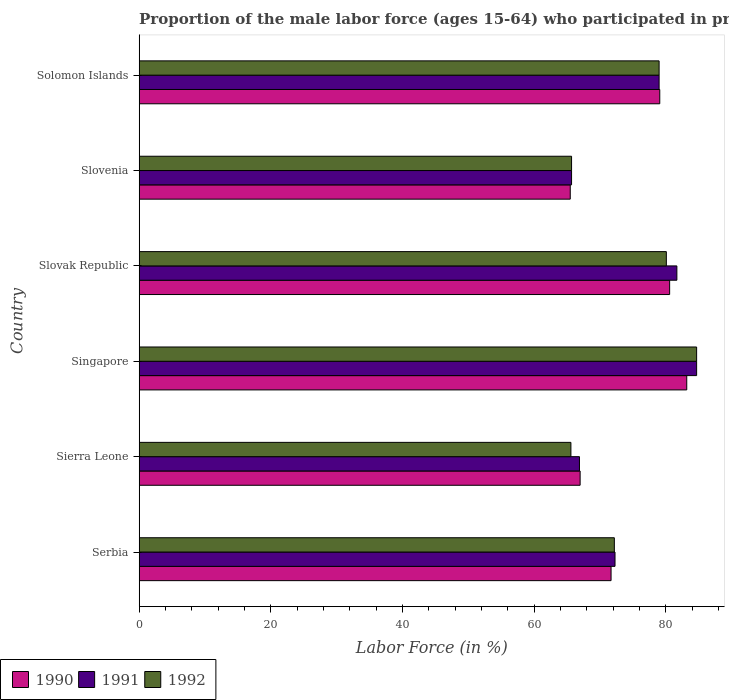Are the number of bars per tick equal to the number of legend labels?
Your answer should be very brief. Yes. How many bars are there on the 5th tick from the bottom?
Provide a short and direct response. 3. What is the label of the 2nd group of bars from the top?
Keep it short and to the point. Slovenia. In how many cases, is the number of bars for a given country not equal to the number of legend labels?
Make the answer very short. 0. Across all countries, what is the maximum proportion of the male labor force who participated in production in 1990?
Provide a short and direct response. 83.2. Across all countries, what is the minimum proportion of the male labor force who participated in production in 1990?
Keep it short and to the point. 65.5. In which country was the proportion of the male labor force who participated in production in 1991 maximum?
Your answer should be compact. Singapore. In which country was the proportion of the male labor force who participated in production in 1992 minimum?
Your response must be concise. Sierra Leone. What is the total proportion of the male labor force who participated in production in 1992 in the graph?
Ensure brevity in your answer.  447.3. What is the difference between the proportion of the male labor force who participated in production in 1991 in Slovak Republic and that in Solomon Islands?
Provide a succinct answer. 2.7. What is the difference between the proportion of the male labor force who participated in production in 1990 in Slovak Republic and the proportion of the male labor force who participated in production in 1992 in Slovenia?
Your answer should be very brief. 14.9. What is the average proportion of the male labor force who participated in production in 1991 per country?
Your response must be concise. 75.05. What is the difference between the proportion of the male labor force who participated in production in 1990 and proportion of the male labor force who participated in production in 1992 in Solomon Islands?
Make the answer very short. 0.1. In how many countries, is the proportion of the male labor force who participated in production in 1991 greater than 4 %?
Offer a very short reply. 6. What is the ratio of the proportion of the male labor force who participated in production in 1992 in Sierra Leone to that in Solomon Islands?
Provide a short and direct response. 0.83. Is the difference between the proportion of the male labor force who participated in production in 1990 in Serbia and Slovenia greater than the difference between the proportion of the male labor force who participated in production in 1992 in Serbia and Slovenia?
Offer a very short reply. No. What is the difference between the highest and the second highest proportion of the male labor force who participated in production in 1990?
Offer a very short reply. 2.6. What is the difference between the highest and the lowest proportion of the male labor force who participated in production in 1990?
Your response must be concise. 17.7. In how many countries, is the proportion of the male labor force who participated in production in 1992 greater than the average proportion of the male labor force who participated in production in 1992 taken over all countries?
Keep it short and to the point. 3. What does the 2nd bar from the bottom in Solomon Islands represents?
Provide a succinct answer. 1991. Is it the case that in every country, the sum of the proportion of the male labor force who participated in production in 1991 and proportion of the male labor force who participated in production in 1992 is greater than the proportion of the male labor force who participated in production in 1990?
Make the answer very short. Yes. How many bars are there?
Provide a succinct answer. 18. Are all the bars in the graph horizontal?
Offer a very short reply. Yes. What is the difference between two consecutive major ticks on the X-axis?
Ensure brevity in your answer.  20. Where does the legend appear in the graph?
Provide a succinct answer. Bottom left. How are the legend labels stacked?
Provide a short and direct response. Horizontal. What is the title of the graph?
Provide a short and direct response. Proportion of the male labor force (ages 15-64) who participated in production. What is the Labor Force (in %) in 1990 in Serbia?
Make the answer very short. 71.7. What is the Labor Force (in %) in 1991 in Serbia?
Offer a terse response. 72.3. What is the Labor Force (in %) in 1992 in Serbia?
Your response must be concise. 72.2. What is the Labor Force (in %) of 1990 in Sierra Leone?
Keep it short and to the point. 67. What is the Labor Force (in %) of 1991 in Sierra Leone?
Your answer should be compact. 66.9. What is the Labor Force (in %) of 1992 in Sierra Leone?
Offer a terse response. 65.6. What is the Labor Force (in %) of 1990 in Singapore?
Make the answer very short. 83.2. What is the Labor Force (in %) in 1991 in Singapore?
Provide a short and direct response. 84.7. What is the Labor Force (in %) in 1992 in Singapore?
Provide a succinct answer. 84.7. What is the Labor Force (in %) in 1990 in Slovak Republic?
Your answer should be very brief. 80.6. What is the Labor Force (in %) of 1991 in Slovak Republic?
Make the answer very short. 81.7. What is the Labor Force (in %) of 1992 in Slovak Republic?
Offer a terse response. 80.1. What is the Labor Force (in %) of 1990 in Slovenia?
Offer a very short reply. 65.5. What is the Labor Force (in %) in 1991 in Slovenia?
Keep it short and to the point. 65.7. What is the Labor Force (in %) of 1992 in Slovenia?
Your answer should be very brief. 65.7. What is the Labor Force (in %) in 1990 in Solomon Islands?
Provide a succinct answer. 79.1. What is the Labor Force (in %) of 1991 in Solomon Islands?
Offer a very short reply. 79. What is the Labor Force (in %) of 1992 in Solomon Islands?
Make the answer very short. 79. Across all countries, what is the maximum Labor Force (in %) in 1990?
Ensure brevity in your answer.  83.2. Across all countries, what is the maximum Labor Force (in %) in 1991?
Keep it short and to the point. 84.7. Across all countries, what is the maximum Labor Force (in %) in 1992?
Offer a very short reply. 84.7. Across all countries, what is the minimum Labor Force (in %) in 1990?
Keep it short and to the point. 65.5. Across all countries, what is the minimum Labor Force (in %) in 1991?
Offer a very short reply. 65.7. Across all countries, what is the minimum Labor Force (in %) in 1992?
Offer a terse response. 65.6. What is the total Labor Force (in %) of 1990 in the graph?
Your response must be concise. 447.1. What is the total Labor Force (in %) of 1991 in the graph?
Provide a succinct answer. 450.3. What is the total Labor Force (in %) in 1992 in the graph?
Your response must be concise. 447.3. What is the difference between the Labor Force (in %) in 1990 in Serbia and that in Sierra Leone?
Offer a very short reply. 4.7. What is the difference between the Labor Force (in %) of 1992 in Serbia and that in Sierra Leone?
Make the answer very short. 6.6. What is the difference between the Labor Force (in %) of 1990 in Serbia and that in Singapore?
Provide a succinct answer. -11.5. What is the difference between the Labor Force (in %) in 1991 in Serbia and that in Singapore?
Provide a succinct answer. -12.4. What is the difference between the Labor Force (in %) in 1991 in Serbia and that in Slovak Republic?
Give a very brief answer. -9.4. What is the difference between the Labor Force (in %) of 1992 in Serbia and that in Slovak Republic?
Ensure brevity in your answer.  -7.9. What is the difference between the Labor Force (in %) of 1991 in Serbia and that in Slovenia?
Provide a succinct answer. 6.6. What is the difference between the Labor Force (in %) of 1992 in Serbia and that in Slovenia?
Your answer should be compact. 6.5. What is the difference between the Labor Force (in %) in 1990 in Sierra Leone and that in Singapore?
Provide a short and direct response. -16.2. What is the difference between the Labor Force (in %) of 1991 in Sierra Leone and that in Singapore?
Your answer should be compact. -17.8. What is the difference between the Labor Force (in %) in 1992 in Sierra Leone and that in Singapore?
Your answer should be very brief. -19.1. What is the difference between the Labor Force (in %) in 1990 in Sierra Leone and that in Slovak Republic?
Keep it short and to the point. -13.6. What is the difference between the Labor Force (in %) of 1991 in Sierra Leone and that in Slovak Republic?
Your answer should be very brief. -14.8. What is the difference between the Labor Force (in %) of 1990 in Sierra Leone and that in Slovenia?
Provide a succinct answer. 1.5. What is the difference between the Labor Force (in %) in 1991 in Sierra Leone and that in Slovenia?
Provide a short and direct response. 1.2. What is the difference between the Labor Force (in %) of 1990 in Sierra Leone and that in Solomon Islands?
Your response must be concise. -12.1. What is the difference between the Labor Force (in %) of 1991 in Singapore and that in Slovak Republic?
Your response must be concise. 3. What is the difference between the Labor Force (in %) in 1992 in Singapore and that in Slovak Republic?
Provide a short and direct response. 4.6. What is the difference between the Labor Force (in %) in 1991 in Singapore and that in Slovenia?
Your response must be concise. 19. What is the difference between the Labor Force (in %) in 1992 in Singapore and that in Slovenia?
Provide a succinct answer. 19. What is the difference between the Labor Force (in %) in 1992 in Singapore and that in Solomon Islands?
Keep it short and to the point. 5.7. What is the difference between the Labor Force (in %) in 1991 in Slovak Republic and that in Slovenia?
Offer a terse response. 16. What is the difference between the Labor Force (in %) of 1992 in Slovak Republic and that in Slovenia?
Provide a succinct answer. 14.4. What is the difference between the Labor Force (in %) of 1991 in Slovak Republic and that in Solomon Islands?
Offer a very short reply. 2.7. What is the difference between the Labor Force (in %) in 1992 in Slovak Republic and that in Solomon Islands?
Your response must be concise. 1.1. What is the difference between the Labor Force (in %) of 1990 in Serbia and the Labor Force (in %) of 1991 in Sierra Leone?
Provide a short and direct response. 4.8. What is the difference between the Labor Force (in %) in 1990 in Serbia and the Labor Force (in %) in 1992 in Sierra Leone?
Give a very brief answer. 6.1. What is the difference between the Labor Force (in %) of 1990 in Serbia and the Labor Force (in %) of 1991 in Singapore?
Offer a terse response. -13. What is the difference between the Labor Force (in %) of 1990 in Serbia and the Labor Force (in %) of 1992 in Singapore?
Offer a terse response. -13. What is the difference between the Labor Force (in %) in 1991 in Serbia and the Labor Force (in %) in 1992 in Singapore?
Your answer should be very brief. -12.4. What is the difference between the Labor Force (in %) of 1990 in Serbia and the Labor Force (in %) of 1992 in Slovenia?
Provide a short and direct response. 6. What is the difference between the Labor Force (in %) in 1991 in Serbia and the Labor Force (in %) in 1992 in Slovenia?
Offer a very short reply. 6.6. What is the difference between the Labor Force (in %) of 1990 in Serbia and the Labor Force (in %) of 1992 in Solomon Islands?
Give a very brief answer. -7.3. What is the difference between the Labor Force (in %) of 1990 in Sierra Leone and the Labor Force (in %) of 1991 in Singapore?
Make the answer very short. -17.7. What is the difference between the Labor Force (in %) of 1990 in Sierra Leone and the Labor Force (in %) of 1992 in Singapore?
Offer a very short reply. -17.7. What is the difference between the Labor Force (in %) in 1991 in Sierra Leone and the Labor Force (in %) in 1992 in Singapore?
Provide a short and direct response. -17.8. What is the difference between the Labor Force (in %) of 1990 in Sierra Leone and the Labor Force (in %) of 1991 in Slovak Republic?
Offer a terse response. -14.7. What is the difference between the Labor Force (in %) of 1990 in Sierra Leone and the Labor Force (in %) of 1992 in Slovak Republic?
Keep it short and to the point. -13.1. What is the difference between the Labor Force (in %) in 1991 in Sierra Leone and the Labor Force (in %) in 1992 in Slovak Republic?
Give a very brief answer. -13.2. What is the difference between the Labor Force (in %) in 1990 in Sierra Leone and the Labor Force (in %) in 1991 in Slovenia?
Give a very brief answer. 1.3. What is the difference between the Labor Force (in %) of 1991 in Sierra Leone and the Labor Force (in %) of 1992 in Slovenia?
Make the answer very short. 1.2. What is the difference between the Labor Force (in %) of 1990 in Singapore and the Labor Force (in %) of 1991 in Slovak Republic?
Offer a very short reply. 1.5. What is the difference between the Labor Force (in %) in 1991 in Singapore and the Labor Force (in %) in 1992 in Slovak Republic?
Offer a very short reply. 4.6. What is the difference between the Labor Force (in %) of 1990 in Singapore and the Labor Force (in %) of 1991 in Solomon Islands?
Offer a very short reply. 4.2. What is the difference between the Labor Force (in %) in 1990 in Singapore and the Labor Force (in %) in 1992 in Solomon Islands?
Keep it short and to the point. 4.2. What is the difference between the Labor Force (in %) in 1990 in Slovak Republic and the Labor Force (in %) in 1991 in Slovenia?
Your response must be concise. 14.9. What is the difference between the Labor Force (in %) of 1990 in Slovak Republic and the Labor Force (in %) of 1992 in Slovenia?
Your answer should be very brief. 14.9. What is the difference between the Labor Force (in %) of 1991 in Slovak Republic and the Labor Force (in %) of 1992 in Slovenia?
Ensure brevity in your answer.  16. What is the difference between the Labor Force (in %) of 1990 in Slovak Republic and the Labor Force (in %) of 1992 in Solomon Islands?
Make the answer very short. 1.6. What is the difference between the Labor Force (in %) in 1990 in Slovenia and the Labor Force (in %) in 1991 in Solomon Islands?
Give a very brief answer. -13.5. What is the difference between the Labor Force (in %) in 1990 in Slovenia and the Labor Force (in %) in 1992 in Solomon Islands?
Your answer should be compact. -13.5. What is the average Labor Force (in %) in 1990 per country?
Ensure brevity in your answer.  74.52. What is the average Labor Force (in %) in 1991 per country?
Offer a terse response. 75.05. What is the average Labor Force (in %) of 1992 per country?
Provide a succinct answer. 74.55. What is the difference between the Labor Force (in %) of 1990 and Labor Force (in %) of 1992 in Serbia?
Offer a very short reply. -0.5. What is the difference between the Labor Force (in %) of 1991 and Labor Force (in %) of 1992 in Serbia?
Give a very brief answer. 0.1. What is the difference between the Labor Force (in %) in 1990 and Labor Force (in %) in 1991 in Sierra Leone?
Offer a very short reply. 0.1. What is the difference between the Labor Force (in %) in 1990 and Labor Force (in %) in 1992 in Sierra Leone?
Make the answer very short. 1.4. What is the difference between the Labor Force (in %) in 1990 and Labor Force (in %) in 1992 in Singapore?
Give a very brief answer. -1.5. What is the difference between the Labor Force (in %) of 1991 and Labor Force (in %) of 1992 in Singapore?
Keep it short and to the point. 0. What is the difference between the Labor Force (in %) of 1990 and Labor Force (in %) of 1991 in Slovak Republic?
Ensure brevity in your answer.  -1.1. What is the difference between the Labor Force (in %) in 1991 and Labor Force (in %) in 1992 in Slovak Republic?
Provide a short and direct response. 1.6. What is the difference between the Labor Force (in %) in 1990 and Labor Force (in %) in 1992 in Slovenia?
Make the answer very short. -0.2. What is the ratio of the Labor Force (in %) of 1990 in Serbia to that in Sierra Leone?
Keep it short and to the point. 1.07. What is the ratio of the Labor Force (in %) in 1991 in Serbia to that in Sierra Leone?
Your answer should be compact. 1.08. What is the ratio of the Labor Force (in %) of 1992 in Serbia to that in Sierra Leone?
Keep it short and to the point. 1.1. What is the ratio of the Labor Force (in %) in 1990 in Serbia to that in Singapore?
Provide a short and direct response. 0.86. What is the ratio of the Labor Force (in %) in 1991 in Serbia to that in Singapore?
Your answer should be very brief. 0.85. What is the ratio of the Labor Force (in %) of 1992 in Serbia to that in Singapore?
Your answer should be compact. 0.85. What is the ratio of the Labor Force (in %) in 1990 in Serbia to that in Slovak Republic?
Keep it short and to the point. 0.89. What is the ratio of the Labor Force (in %) in 1991 in Serbia to that in Slovak Republic?
Give a very brief answer. 0.88. What is the ratio of the Labor Force (in %) of 1992 in Serbia to that in Slovak Republic?
Keep it short and to the point. 0.9. What is the ratio of the Labor Force (in %) in 1990 in Serbia to that in Slovenia?
Make the answer very short. 1.09. What is the ratio of the Labor Force (in %) of 1991 in Serbia to that in Slovenia?
Offer a very short reply. 1.1. What is the ratio of the Labor Force (in %) of 1992 in Serbia to that in Slovenia?
Provide a short and direct response. 1.1. What is the ratio of the Labor Force (in %) in 1990 in Serbia to that in Solomon Islands?
Offer a terse response. 0.91. What is the ratio of the Labor Force (in %) in 1991 in Serbia to that in Solomon Islands?
Provide a succinct answer. 0.92. What is the ratio of the Labor Force (in %) of 1992 in Serbia to that in Solomon Islands?
Make the answer very short. 0.91. What is the ratio of the Labor Force (in %) in 1990 in Sierra Leone to that in Singapore?
Make the answer very short. 0.81. What is the ratio of the Labor Force (in %) of 1991 in Sierra Leone to that in Singapore?
Provide a short and direct response. 0.79. What is the ratio of the Labor Force (in %) in 1992 in Sierra Leone to that in Singapore?
Make the answer very short. 0.77. What is the ratio of the Labor Force (in %) of 1990 in Sierra Leone to that in Slovak Republic?
Your answer should be very brief. 0.83. What is the ratio of the Labor Force (in %) in 1991 in Sierra Leone to that in Slovak Republic?
Keep it short and to the point. 0.82. What is the ratio of the Labor Force (in %) in 1992 in Sierra Leone to that in Slovak Republic?
Make the answer very short. 0.82. What is the ratio of the Labor Force (in %) in 1990 in Sierra Leone to that in Slovenia?
Offer a very short reply. 1.02. What is the ratio of the Labor Force (in %) of 1991 in Sierra Leone to that in Slovenia?
Keep it short and to the point. 1.02. What is the ratio of the Labor Force (in %) of 1990 in Sierra Leone to that in Solomon Islands?
Your answer should be compact. 0.85. What is the ratio of the Labor Force (in %) of 1991 in Sierra Leone to that in Solomon Islands?
Your answer should be compact. 0.85. What is the ratio of the Labor Force (in %) of 1992 in Sierra Leone to that in Solomon Islands?
Offer a terse response. 0.83. What is the ratio of the Labor Force (in %) in 1990 in Singapore to that in Slovak Republic?
Your answer should be very brief. 1.03. What is the ratio of the Labor Force (in %) of 1991 in Singapore to that in Slovak Republic?
Make the answer very short. 1.04. What is the ratio of the Labor Force (in %) of 1992 in Singapore to that in Slovak Republic?
Your answer should be very brief. 1.06. What is the ratio of the Labor Force (in %) of 1990 in Singapore to that in Slovenia?
Make the answer very short. 1.27. What is the ratio of the Labor Force (in %) of 1991 in Singapore to that in Slovenia?
Provide a succinct answer. 1.29. What is the ratio of the Labor Force (in %) of 1992 in Singapore to that in Slovenia?
Make the answer very short. 1.29. What is the ratio of the Labor Force (in %) in 1990 in Singapore to that in Solomon Islands?
Ensure brevity in your answer.  1.05. What is the ratio of the Labor Force (in %) in 1991 in Singapore to that in Solomon Islands?
Keep it short and to the point. 1.07. What is the ratio of the Labor Force (in %) in 1992 in Singapore to that in Solomon Islands?
Ensure brevity in your answer.  1.07. What is the ratio of the Labor Force (in %) in 1990 in Slovak Republic to that in Slovenia?
Provide a short and direct response. 1.23. What is the ratio of the Labor Force (in %) of 1991 in Slovak Republic to that in Slovenia?
Your answer should be compact. 1.24. What is the ratio of the Labor Force (in %) of 1992 in Slovak Republic to that in Slovenia?
Offer a very short reply. 1.22. What is the ratio of the Labor Force (in %) in 1990 in Slovak Republic to that in Solomon Islands?
Provide a succinct answer. 1.02. What is the ratio of the Labor Force (in %) of 1991 in Slovak Republic to that in Solomon Islands?
Provide a succinct answer. 1.03. What is the ratio of the Labor Force (in %) of 1992 in Slovak Republic to that in Solomon Islands?
Offer a terse response. 1.01. What is the ratio of the Labor Force (in %) of 1990 in Slovenia to that in Solomon Islands?
Make the answer very short. 0.83. What is the ratio of the Labor Force (in %) of 1991 in Slovenia to that in Solomon Islands?
Provide a succinct answer. 0.83. What is the ratio of the Labor Force (in %) in 1992 in Slovenia to that in Solomon Islands?
Offer a very short reply. 0.83. What is the difference between the highest and the second highest Labor Force (in %) of 1990?
Provide a short and direct response. 2.6. What is the difference between the highest and the second highest Labor Force (in %) in 1991?
Your answer should be compact. 3. What is the difference between the highest and the lowest Labor Force (in %) in 1992?
Make the answer very short. 19.1. 